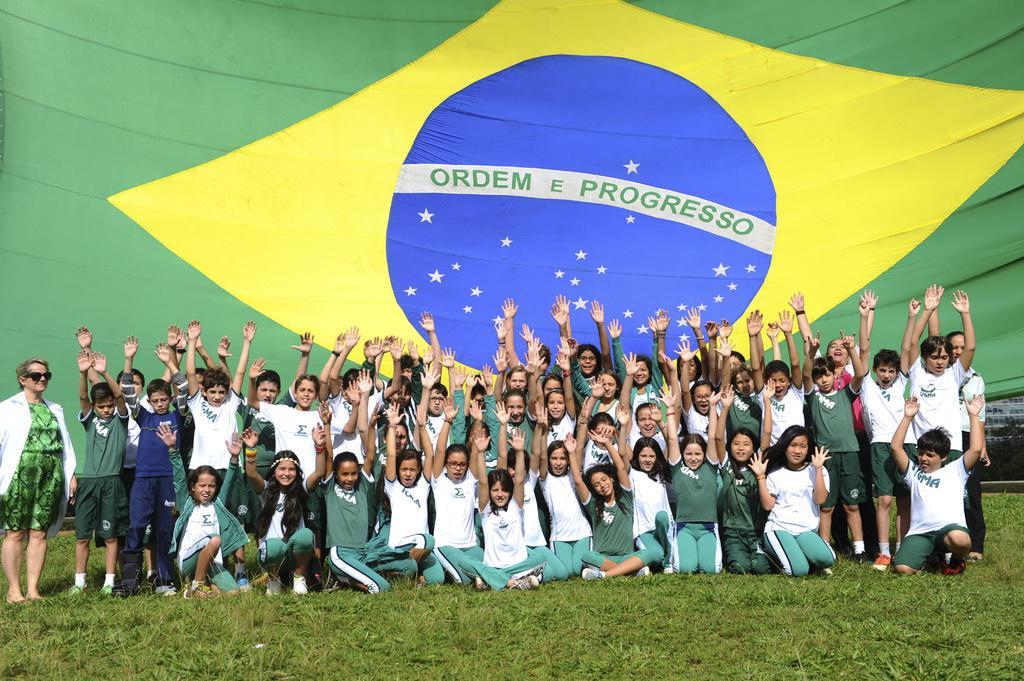Could you give a brief overview of what you see in this image? In this picture I can see few people are standing and few people are seated and raising their hands and I can see a woman standing on the side and I can see a flag in the back and I can see grass on the ground. 